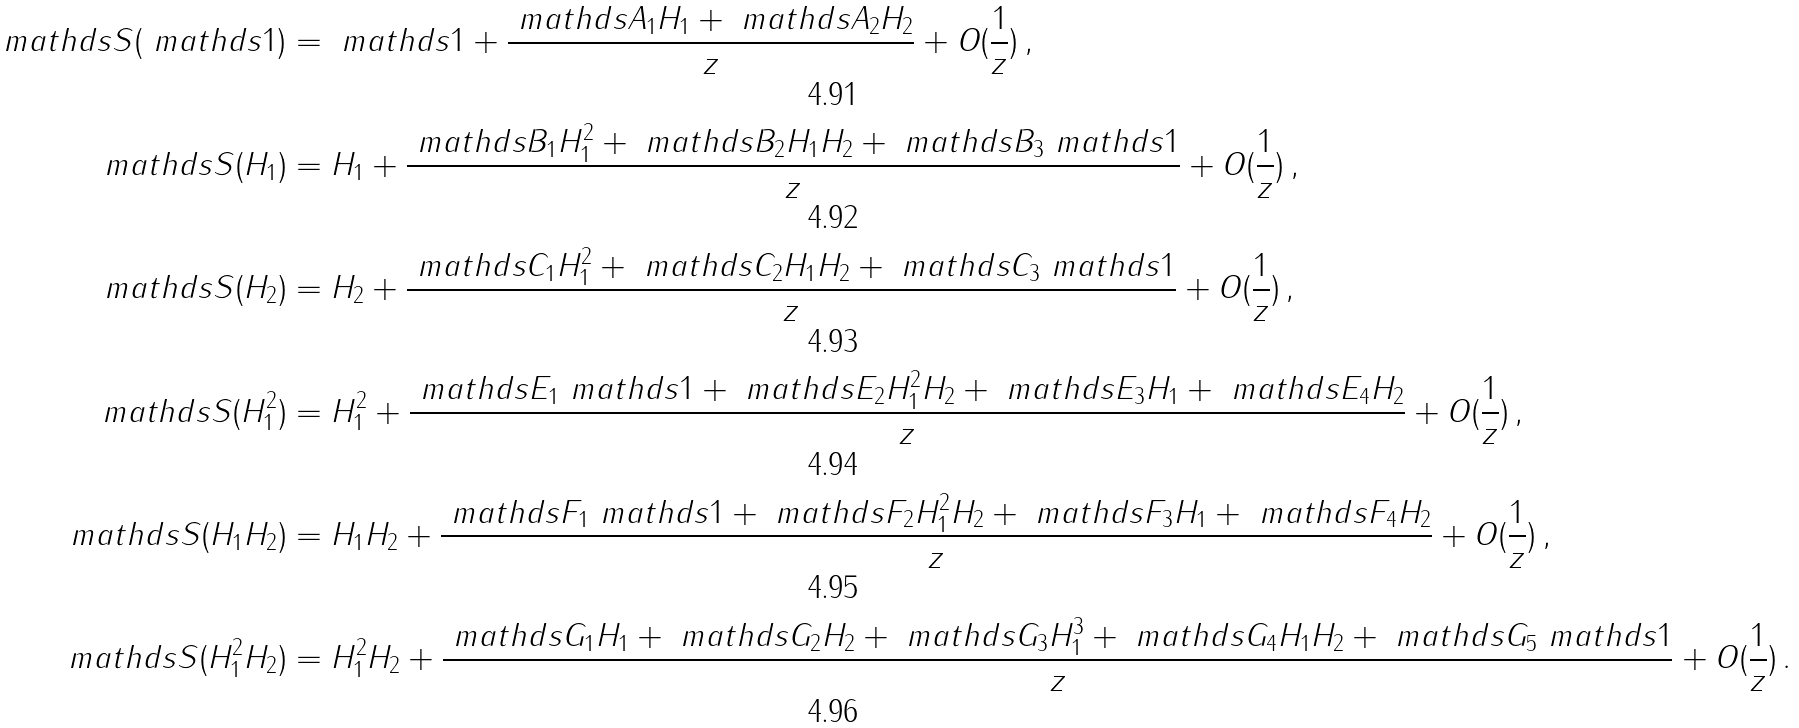<formula> <loc_0><loc_0><loc_500><loc_500>\ m a t h d s { S } ( \ m a t h d s { 1 } ) & = \ m a t h d s { 1 } + \frac { \ m a t h d s { A } _ { 1 } H _ { 1 } + \ m a t h d s { A } _ { 2 } H _ { 2 } } { z } + O ( \frac { 1 } { z } ) \, , \\ \ m a t h d s { S } ( H _ { 1 } ) & = H _ { 1 } + \frac { \ m a t h d s { B } _ { 1 } H _ { 1 } ^ { 2 } + \ m a t h d s { B } _ { 2 } H _ { 1 } H _ { 2 } + \ m a t h d s { B } _ { 3 } \ m a t h d s { 1 } } { z } + O ( \frac { 1 } { z } ) \, , \\ \ m a t h d s { S } ( H _ { 2 } ) & = H _ { 2 } + \frac { \ m a t h d s { C } _ { 1 } H _ { 1 } ^ { 2 } + \ m a t h d s { C } _ { 2 } H _ { 1 } H _ { 2 } + \ m a t h d s { C } _ { 3 } \ m a t h d s { 1 } } { z } + O ( \frac { 1 } { z } ) \, , \\ \ m a t h d s { S } ( H _ { 1 } ^ { 2 } ) & = H _ { 1 } ^ { 2 } + \frac { \ m a t h d s { E } _ { 1 } \ m a t h d s { 1 } + \ m a t h d s { E } _ { 2 } H _ { 1 } ^ { 2 } H _ { 2 } + \ m a t h d s { E } _ { 3 } H _ { 1 } + \ m a t h d s { E } _ { 4 } H _ { 2 } } { z } + O ( \frac { 1 } { z } ) \, , \\ \ m a t h d s { S } ( H _ { 1 } H _ { 2 } ) & = H _ { 1 } H _ { 2 } + \frac { \ m a t h d s { F } _ { 1 } \ m a t h d s { 1 } + \ m a t h d s { F } _ { 2 } H _ { 1 } ^ { 2 } H _ { 2 } + \ m a t h d s { F } _ { 3 } H _ { 1 } + \ m a t h d s { F } _ { 4 } H _ { 2 } } { z } + O ( \frac { 1 } { z } ) \, , \\ \ m a t h d s { S } ( H _ { 1 } ^ { 2 } H _ { 2 } ) & = H _ { 1 } ^ { 2 } H _ { 2 } + \frac { \ m a t h d s { G } _ { 1 } H _ { 1 } + \ m a t h d s { G } _ { 2 } H _ { 2 } + \ m a t h d s { G } _ { 3 } H _ { 1 } ^ { 3 } + \ m a t h d s { G } _ { 4 } H _ { 1 } H _ { 2 } + \ m a t h d s { G } _ { 5 } \ m a t h d s { 1 } } { z } + O ( \frac { 1 } { z } ) \, .</formula> 